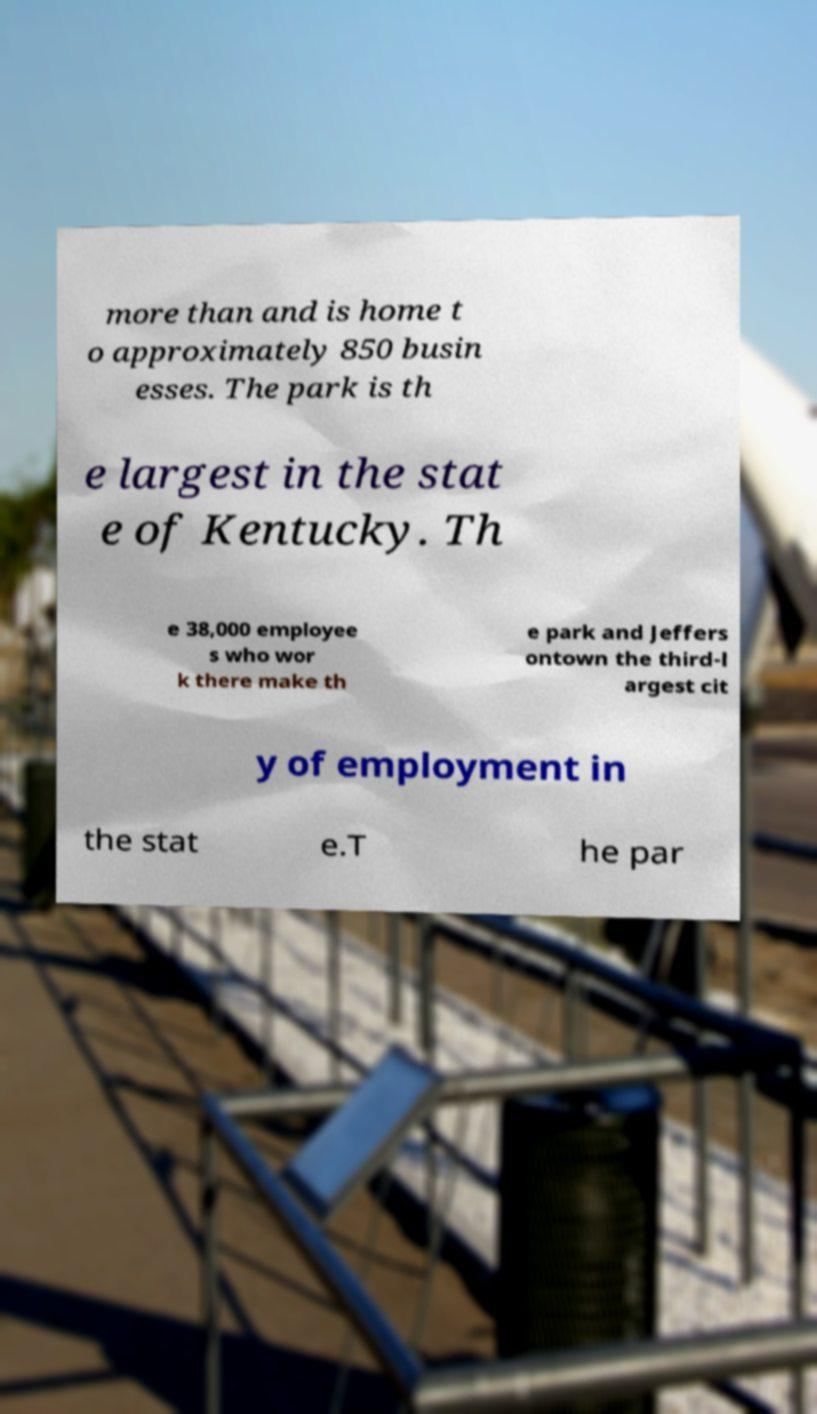Can you accurately transcribe the text from the provided image for me? more than and is home t o approximately 850 busin esses. The park is th e largest in the stat e of Kentucky. Th e 38,000 employee s who wor k there make th e park and Jeffers ontown the third-l argest cit y of employment in the stat e.T he par 